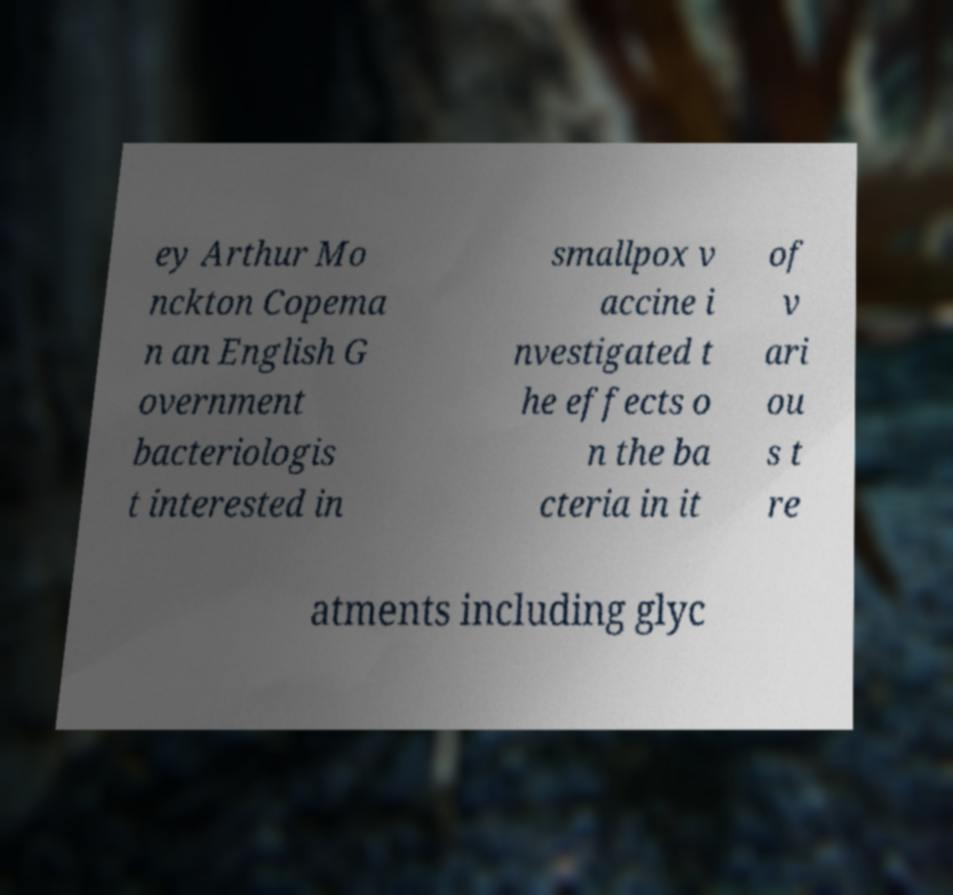There's text embedded in this image that I need extracted. Can you transcribe it verbatim? ey Arthur Mo nckton Copema n an English G overnment bacteriologis t interested in smallpox v accine i nvestigated t he effects o n the ba cteria in it of v ari ou s t re atments including glyc 